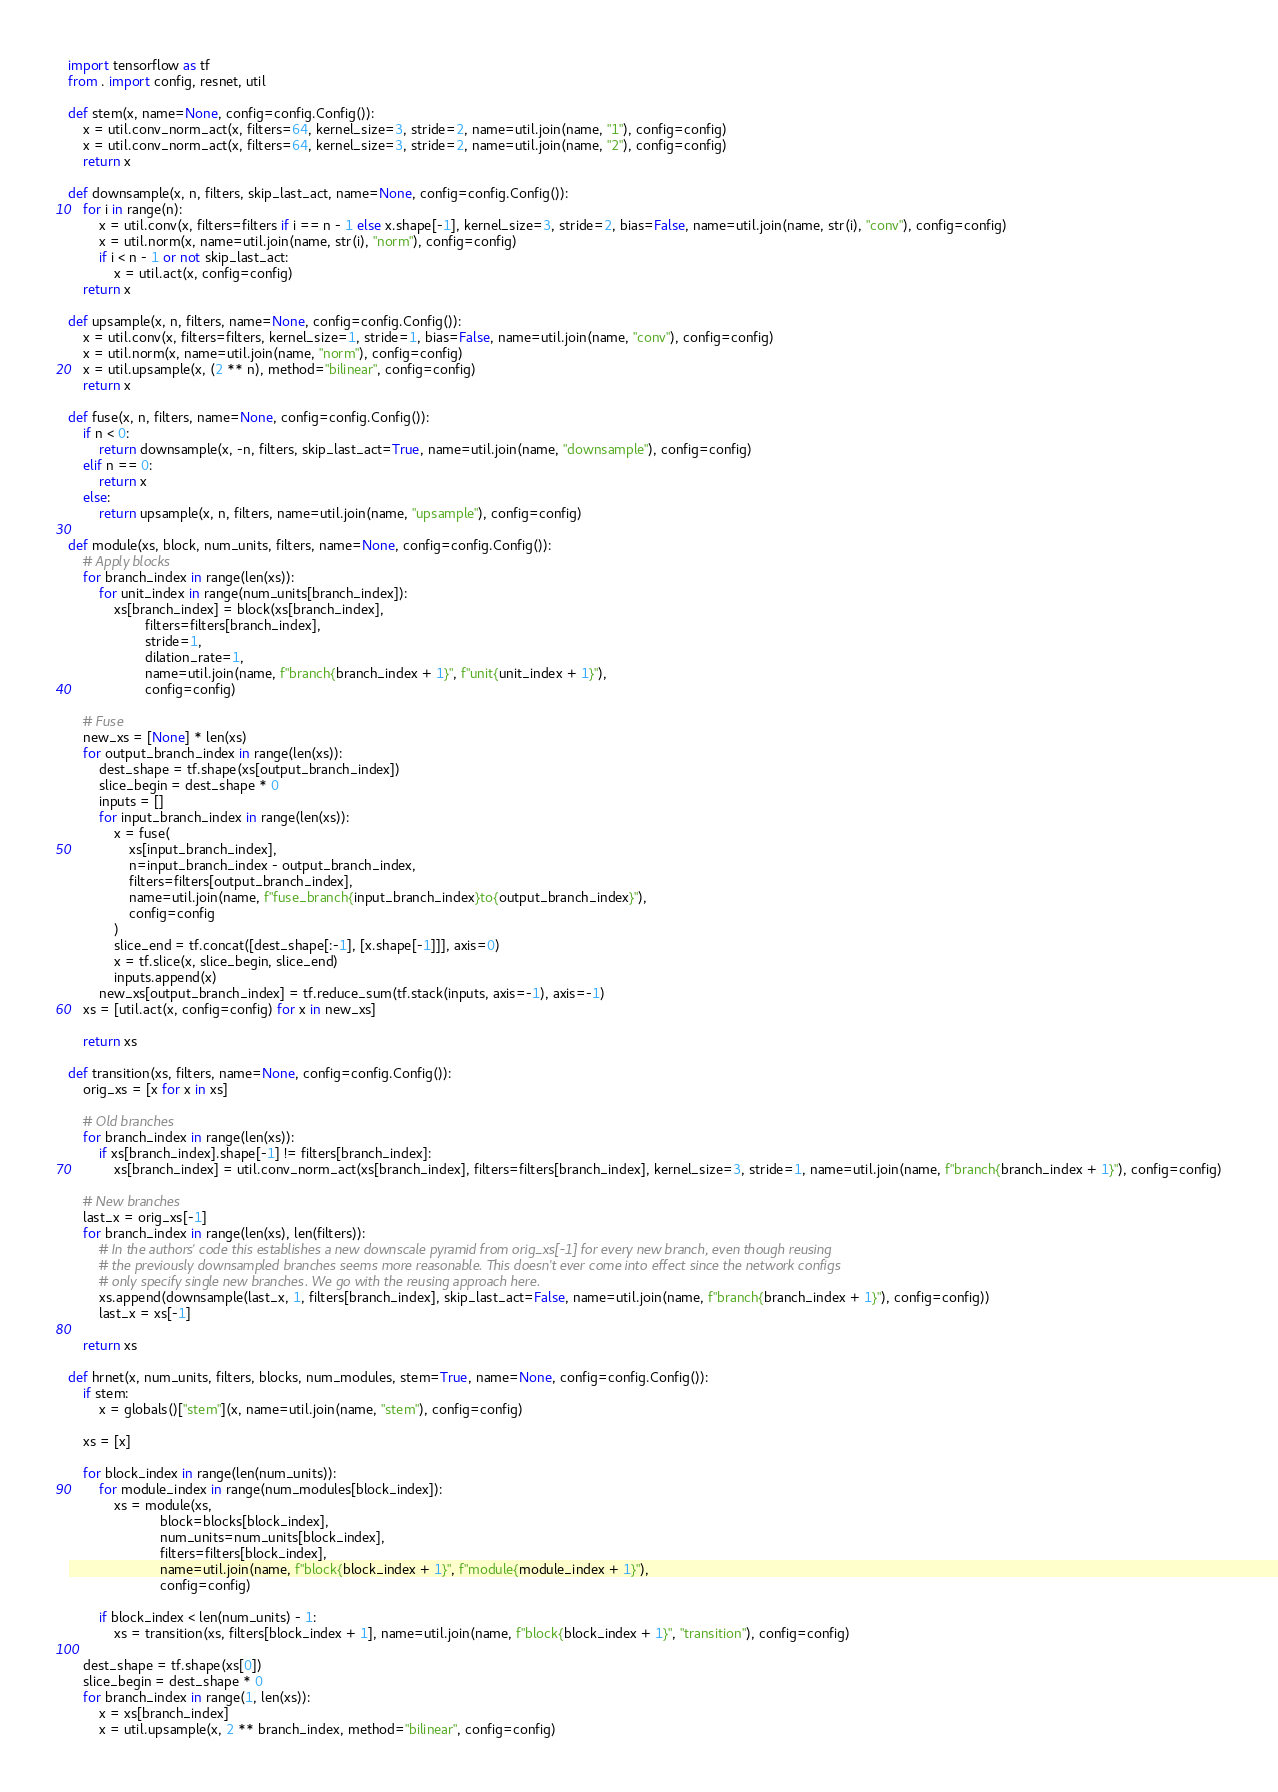Convert code to text. <code><loc_0><loc_0><loc_500><loc_500><_Python_>import tensorflow as tf
from . import config, resnet, util

def stem(x, name=None, config=config.Config()):
    x = util.conv_norm_act(x, filters=64, kernel_size=3, stride=2, name=util.join(name, "1"), config=config)
    x = util.conv_norm_act(x, filters=64, kernel_size=3, stride=2, name=util.join(name, "2"), config=config)
    return x

def downsample(x, n, filters, skip_last_act, name=None, config=config.Config()):
    for i in range(n):
        x = util.conv(x, filters=filters if i == n - 1 else x.shape[-1], kernel_size=3, stride=2, bias=False, name=util.join(name, str(i), "conv"), config=config)
        x = util.norm(x, name=util.join(name, str(i), "norm"), config=config)
        if i < n - 1 or not skip_last_act:
            x = util.act(x, config=config)
    return x

def upsample(x, n, filters, name=None, config=config.Config()):
    x = util.conv(x, filters=filters, kernel_size=1, stride=1, bias=False, name=util.join(name, "conv"), config=config)
    x = util.norm(x, name=util.join(name, "norm"), config=config)
    x = util.upsample(x, (2 ** n), method="bilinear", config=config)
    return x

def fuse(x, n, filters, name=None, config=config.Config()):
    if n < 0:
        return downsample(x, -n, filters, skip_last_act=True, name=util.join(name, "downsample"), config=config)
    elif n == 0:
        return x
    else:
        return upsample(x, n, filters, name=util.join(name, "upsample"), config=config)

def module(xs, block, num_units, filters, name=None, config=config.Config()):
    # Apply blocks
    for branch_index in range(len(xs)):
        for unit_index in range(num_units[branch_index]):
            xs[branch_index] = block(xs[branch_index],
                    filters=filters[branch_index],
                    stride=1,
                    dilation_rate=1,
                    name=util.join(name, f"branch{branch_index + 1}", f"unit{unit_index + 1}"),
                    config=config)

    # Fuse
    new_xs = [None] * len(xs)
    for output_branch_index in range(len(xs)):
        dest_shape = tf.shape(xs[output_branch_index])
        slice_begin = dest_shape * 0
        inputs = []
        for input_branch_index in range(len(xs)):
            x = fuse(
                xs[input_branch_index],
                n=input_branch_index - output_branch_index,
                filters=filters[output_branch_index],
                name=util.join(name, f"fuse_branch{input_branch_index}to{output_branch_index}"),
                config=config
            )
            slice_end = tf.concat([dest_shape[:-1], [x.shape[-1]]], axis=0)
            x = tf.slice(x, slice_begin, slice_end)
            inputs.append(x)
        new_xs[output_branch_index] = tf.reduce_sum(tf.stack(inputs, axis=-1), axis=-1)
    xs = [util.act(x, config=config) for x in new_xs]

    return xs

def transition(xs, filters, name=None, config=config.Config()):
    orig_xs = [x for x in xs]

    # Old branches
    for branch_index in range(len(xs)):
        if xs[branch_index].shape[-1] != filters[branch_index]:
            xs[branch_index] = util.conv_norm_act(xs[branch_index], filters=filters[branch_index], kernel_size=3, stride=1, name=util.join(name, f"branch{branch_index + 1}"), config=config)

    # New branches
    last_x = orig_xs[-1]
    for branch_index in range(len(xs), len(filters)):
        # In the authors' code this establishes a new downscale pyramid from orig_xs[-1] for every new branch, even though reusing
        # the previously downsampled branches seems more reasonable. This doesn't ever come into effect since the network configs
        # only specify single new branches. We go with the reusing approach here.
        xs.append(downsample(last_x, 1, filters[branch_index], skip_last_act=False, name=util.join(name, f"branch{branch_index + 1}"), config=config))
        last_x = xs[-1]

    return xs

def hrnet(x, num_units, filters, blocks, num_modules, stem=True, name=None, config=config.Config()):
    if stem:
        x = globals()["stem"](x, name=util.join(name, "stem"), config=config)

    xs = [x]

    for block_index in range(len(num_units)):
        for module_index in range(num_modules[block_index]):
            xs = module(xs,
                        block=blocks[block_index],
                        num_units=num_units[block_index],
                        filters=filters[block_index],
                        name=util.join(name, f"block{block_index + 1}", f"module{module_index + 1}"),
                        config=config)

        if block_index < len(num_units) - 1:
            xs = transition(xs, filters[block_index + 1], name=util.join(name, f"block{block_index + 1}", "transition"), config=config)

    dest_shape = tf.shape(xs[0])
    slice_begin = dest_shape * 0
    for branch_index in range(1, len(xs)):
        x = xs[branch_index]
        x = util.upsample(x, 2 ** branch_index, method="bilinear", config=config)</code> 